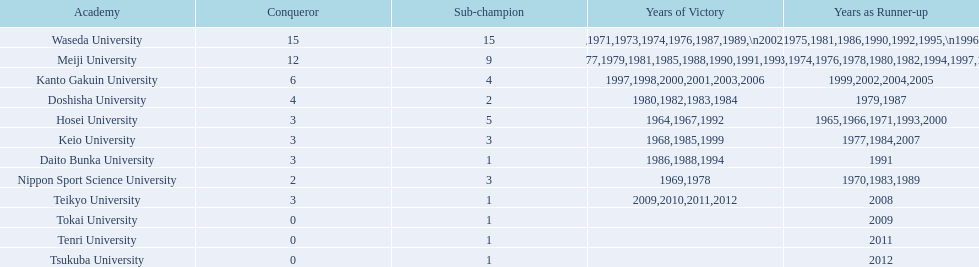What university were there in the all-japan university rugby championship? Waseda University, Meiji University, Kanto Gakuin University, Doshisha University, Hosei University, Keio University, Daito Bunka University, Nippon Sport Science University, Teikyo University, Tokai University, Tenri University, Tsukuba University. Of these who had more than 12 wins? Waseda University. 